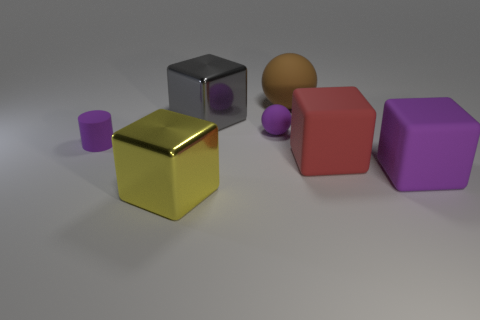Describe the texture and appearance of the objects in the image. The objects in the image display a variety of textures and colors. The cube in the foreground has a reflective gold surface, while the matte ball to its right has a muted, non-reflective surface. The purple object to the rightmost appears smooth with a slightly reflective quality, and the red object in the middle has a similar texture. To the left, there is a smaller object with a rubbery texture. 